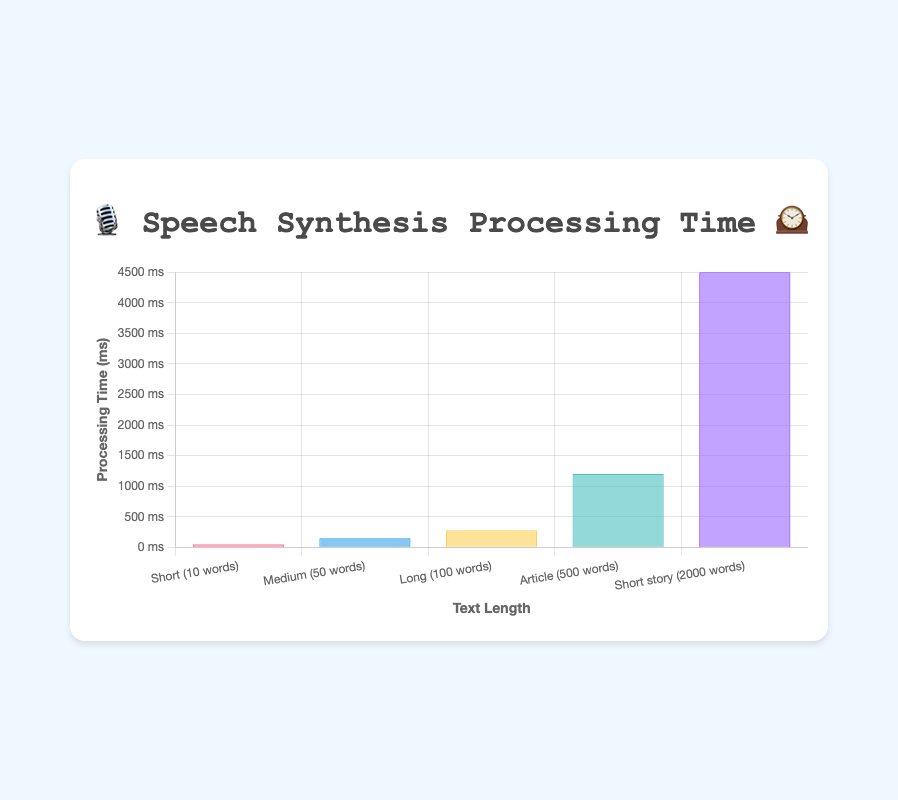What's the title of the chart? The title is usually displayed at the top of the chart in a larger font size to quickly inform the viewer of the information being presented. In this case, the title at the top of the chart is "🎙️ Speech Synthesis Processing Time 🕰️".
Answer: 🎙️ Speech Synthesis Processing Time 🕰️ What does the y-axis represent? The y-axis is labeled with the units of measurement or the variable being plotted. Here, the y-axis represents the "Processing Time (ms)" for the speech synthesis of different text lengths.
Answer: Processing Time (ms) Which text length has the shortest processing time? By comparing the heights of the bars, the shortest one identifies the shortest processing time. The bar labeled "Short (10 words)" is the shortest, representing the shortest processing time.
Answer: Short (10 words) Which emoji represents the longest processing time? By looking at the tooltip information or the context, the longest processing time is associated with the highest bar. The emoji for "Short story (2000 words)" is 🦕, representing the longest processing time.
Answer: 🦕 How much longer does it take to process an "Article (500 words)" compared to a "Medium (50 words)" text? Subtract the processing time of the shorter text from the longer text: 1200 ms (Article) - 150 ms (Medium). The difference is 1050 ms, indicating that it takes 1050 ms longer to process an Article compared to a Medium text.
Answer: 1050 ms What is the total processing time for all the text lengths combined? Add all the processing times together: 50 ms + 150 ms + 280 ms + 1200 ms + 4500 ms gives the total processing time. This adds up to 6180 ms.
Answer: 6180 ms What's the average processing time across all text lengths? Calculate by summing all processing times and dividing by the number of data points: (50 + 150 + 280 + 1200 + 4500) ms / 5 equals 1236 ms.
Answer: 1236 ms Compare the processing times for "Short story (2000 words)" and "Long (100 words)". How many times greater is the processing time for "Short story"? Divide the processing time of "Short story" by that of "Long": 4500 ms (Short story) / 280 ms (Long), which results in approximately 16.07 times greater.
Answer: ~16 times Which text length corresponds to the emoji 🐘 and how long is its processing time? Identify the text length associated with the emoji 🐘 in the tooltip or data. It corresponds to "Article (500 words)" with a processing time of 1200 ms.
Answer: Article (500 words), 1200 ms What's the difference in processing time between "Medium (50 words)" and "Long (100 words)" texts? Subtract the processing time of "Medium" from "Long": 280 ms (Long) - 150 ms (Medium). The difference is 130 ms.
Answer: 130 ms 